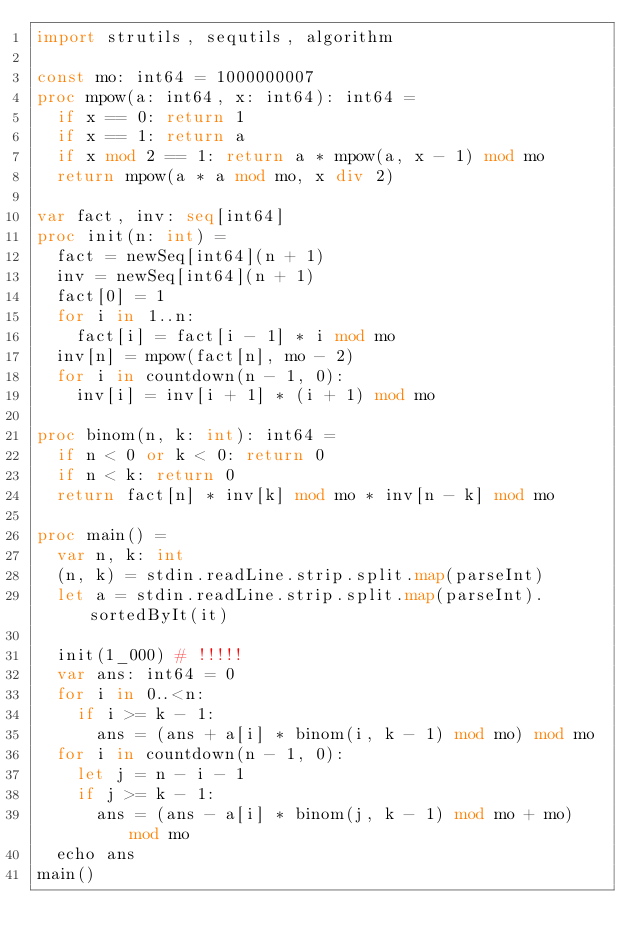<code> <loc_0><loc_0><loc_500><loc_500><_Nim_>import strutils, sequtils, algorithm

const mo: int64 = 1000000007
proc mpow(a: int64, x: int64): int64 =
  if x == 0: return 1
  if x == 1: return a
  if x mod 2 == 1: return a * mpow(a, x - 1) mod mo
  return mpow(a * a mod mo, x div 2)

var fact, inv: seq[int64]
proc init(n: int) =
  fact = newSeq[int64](n + 1)
  inv = newSeq[int64](n + 1)
  fact[0] = 1
  for i in 1..n:
    fact[i] = fact[i - 1] * i mod mo
  inv[n] = mpow(fact[n], mo - 2)
  for i in countdown(n - 1, 0):
    inv[i] = inv[i + 1] * (i + 1) mod mo

proc binom(n, k: int): int64 =
  if n < 0 or k < 0: return 0
  if n < k: return 0
  return fact[n] * inv[k] mod mo * inv[n - k] mod mo

proc main() =
  var n, k: int
  (n, k) = stdin.readLine.strip.split.map(parseInt)
  let a = stdin.readLine.strip.split.map(parseInt).sortedByIt(it)

  init(1_000) # !!!!!
  var ans: int64 = 0
  for i in 0..<n:
    if i >= k - 1:
      ans = (ans + a[i] * binom(i, k - 1) mod mo) mod mo
  for i in countdown(n - 1, 0):
    let j = n - i - 1
    if j >= k - 1:
      ans = (ans - a[i] * binom(j, k - 1) mod mo + mo) mod mo
  echo ans
main()
</code> 